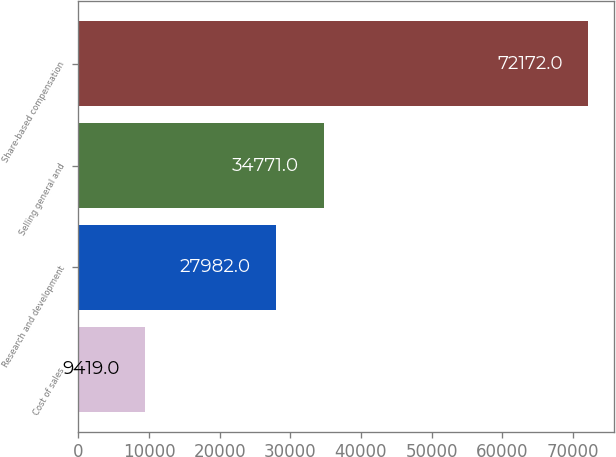Convert chart to OTSL. <chart><loc_0><loc_0><loc_500><loc_500><bar_chart><fcel>Cost of sales<fcel>Research and development<fcel>Selling general and<fcel>Share-based compensation<nl><fcel>9419<fcel>27982<fcel>34771<fcel>72172<nl></chart> 